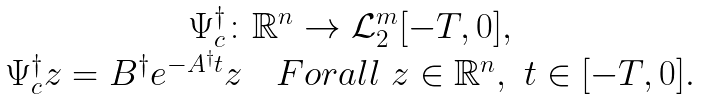<formula> <loc_0><loc_0><loc_500><loc_500>\begin{array} { c } \Psi _ { c } ^ { \dagger } \colon \mathbb { R } ^ { n } \to \mathcal { L } ^ { m } _ { 2 } [ - T , 0 ] , \\ \Psi _ { c } ^ { \dagger } z = B ^ { \dagger } e ^ { - A ^ { \dagger } t } z \quad F o r a l l \ z \in \mathbb { R } ^ { n } , \ t \in [ - T , 0 ] . \end{array}</formula> 